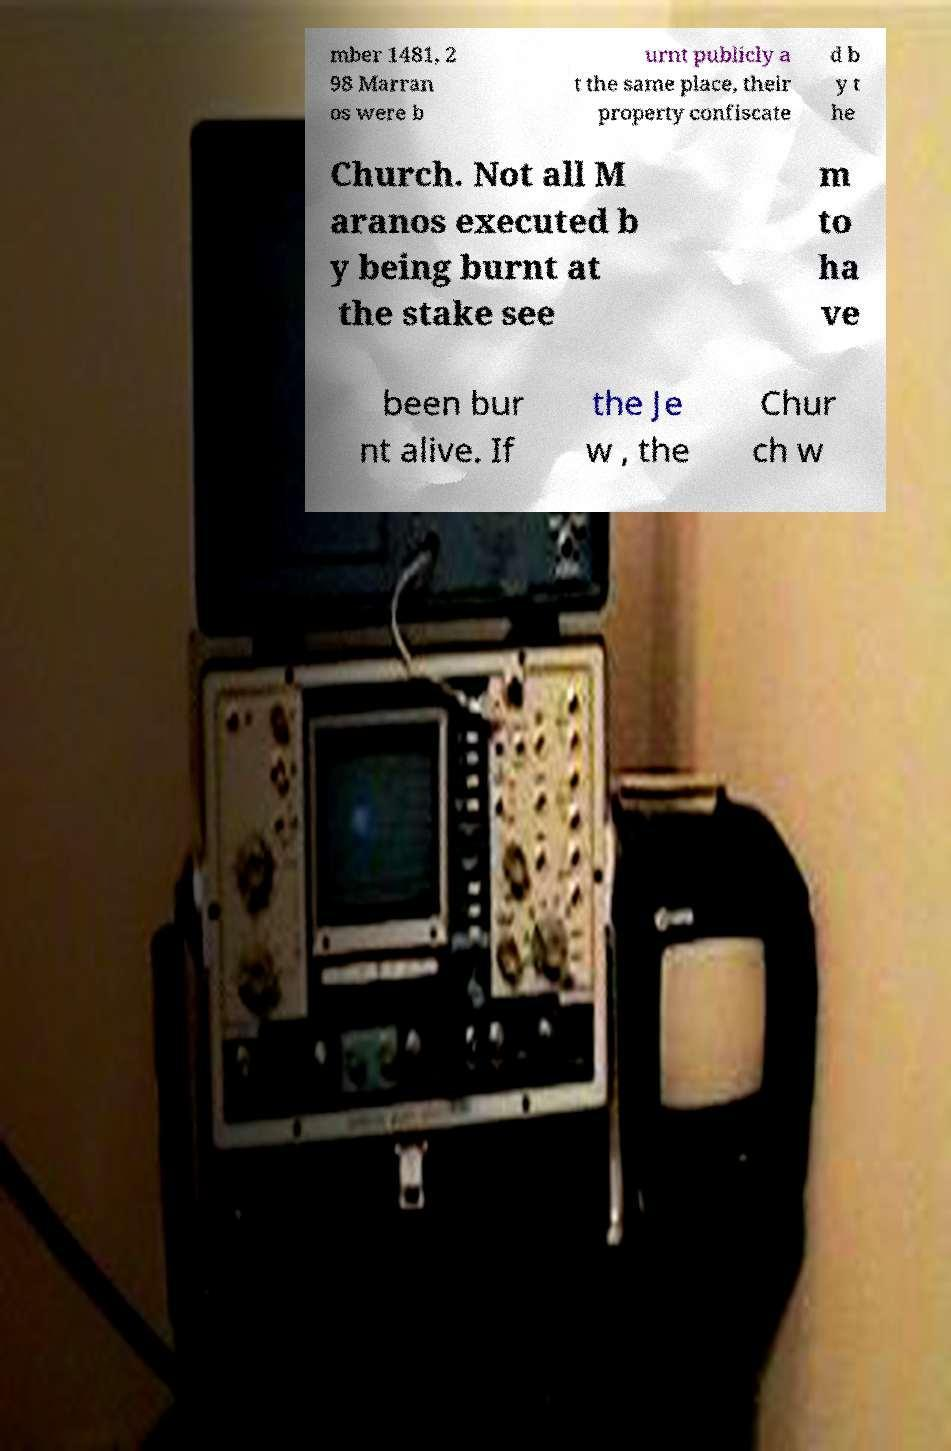I need the written content from this picture converted into text. Can you do that? mber 1481, 2 98 Marran os were b urnt publicly a t the same place, their property confiscate d b y t he Church. Not all M aranos executed b y being burnt at the stake see m to ha ve been bur nt alive. If the Je w , the Chur ch w 